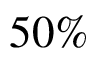<formula> <loc_0><loc_0><loc_500><loc_500>5 0 \%</formula> 